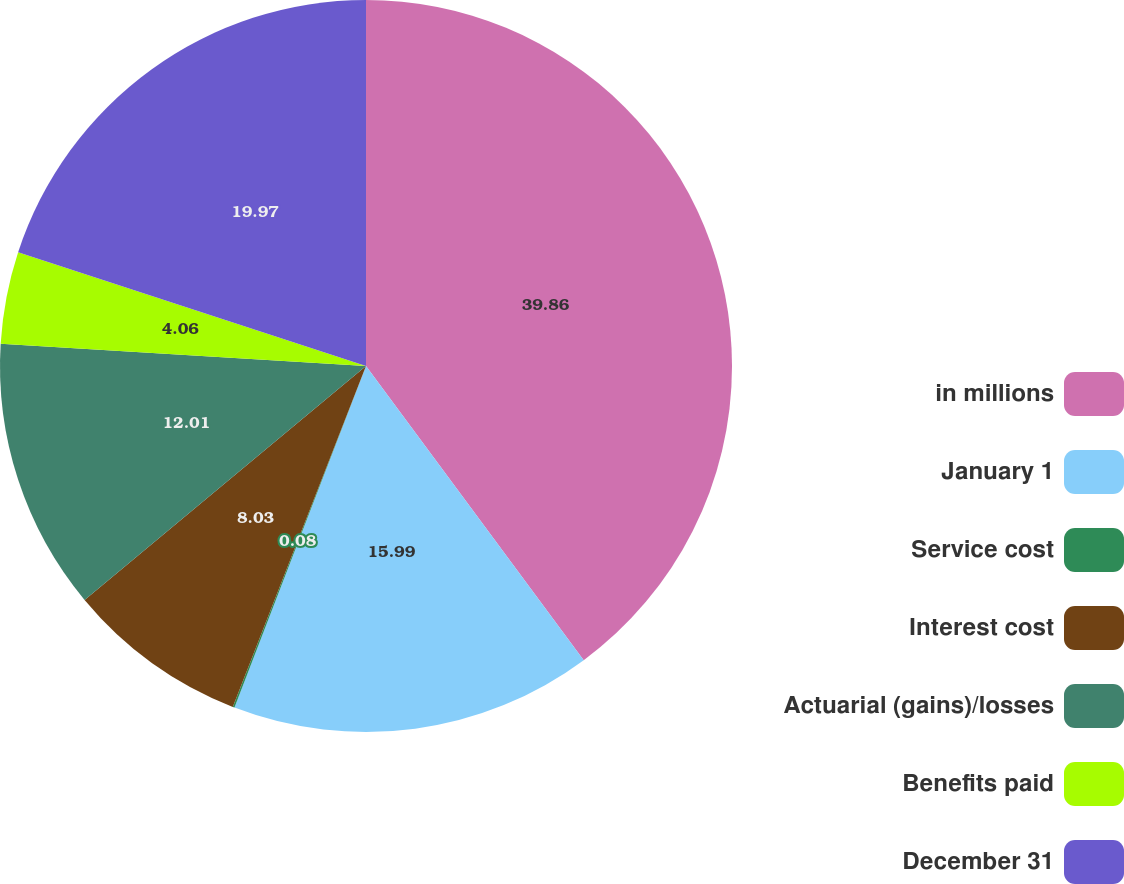Convert chart. <chart><loc_0><loc_0><loc_500><loc_500><pie_chart><fcel>in millions<fcel>January 1<fcel>Service cost<fcel>Interest cost<fcel>Actuarial (gains)/losses<fcel>Benefits paid<fcel>December 31<nl><fcel>39.86%<fcel>15.99%<fcel>0.08%<fcel>8.03%<fcel>12.01%<fcel>4.06%<fcel>19.97%<nl></chart> 